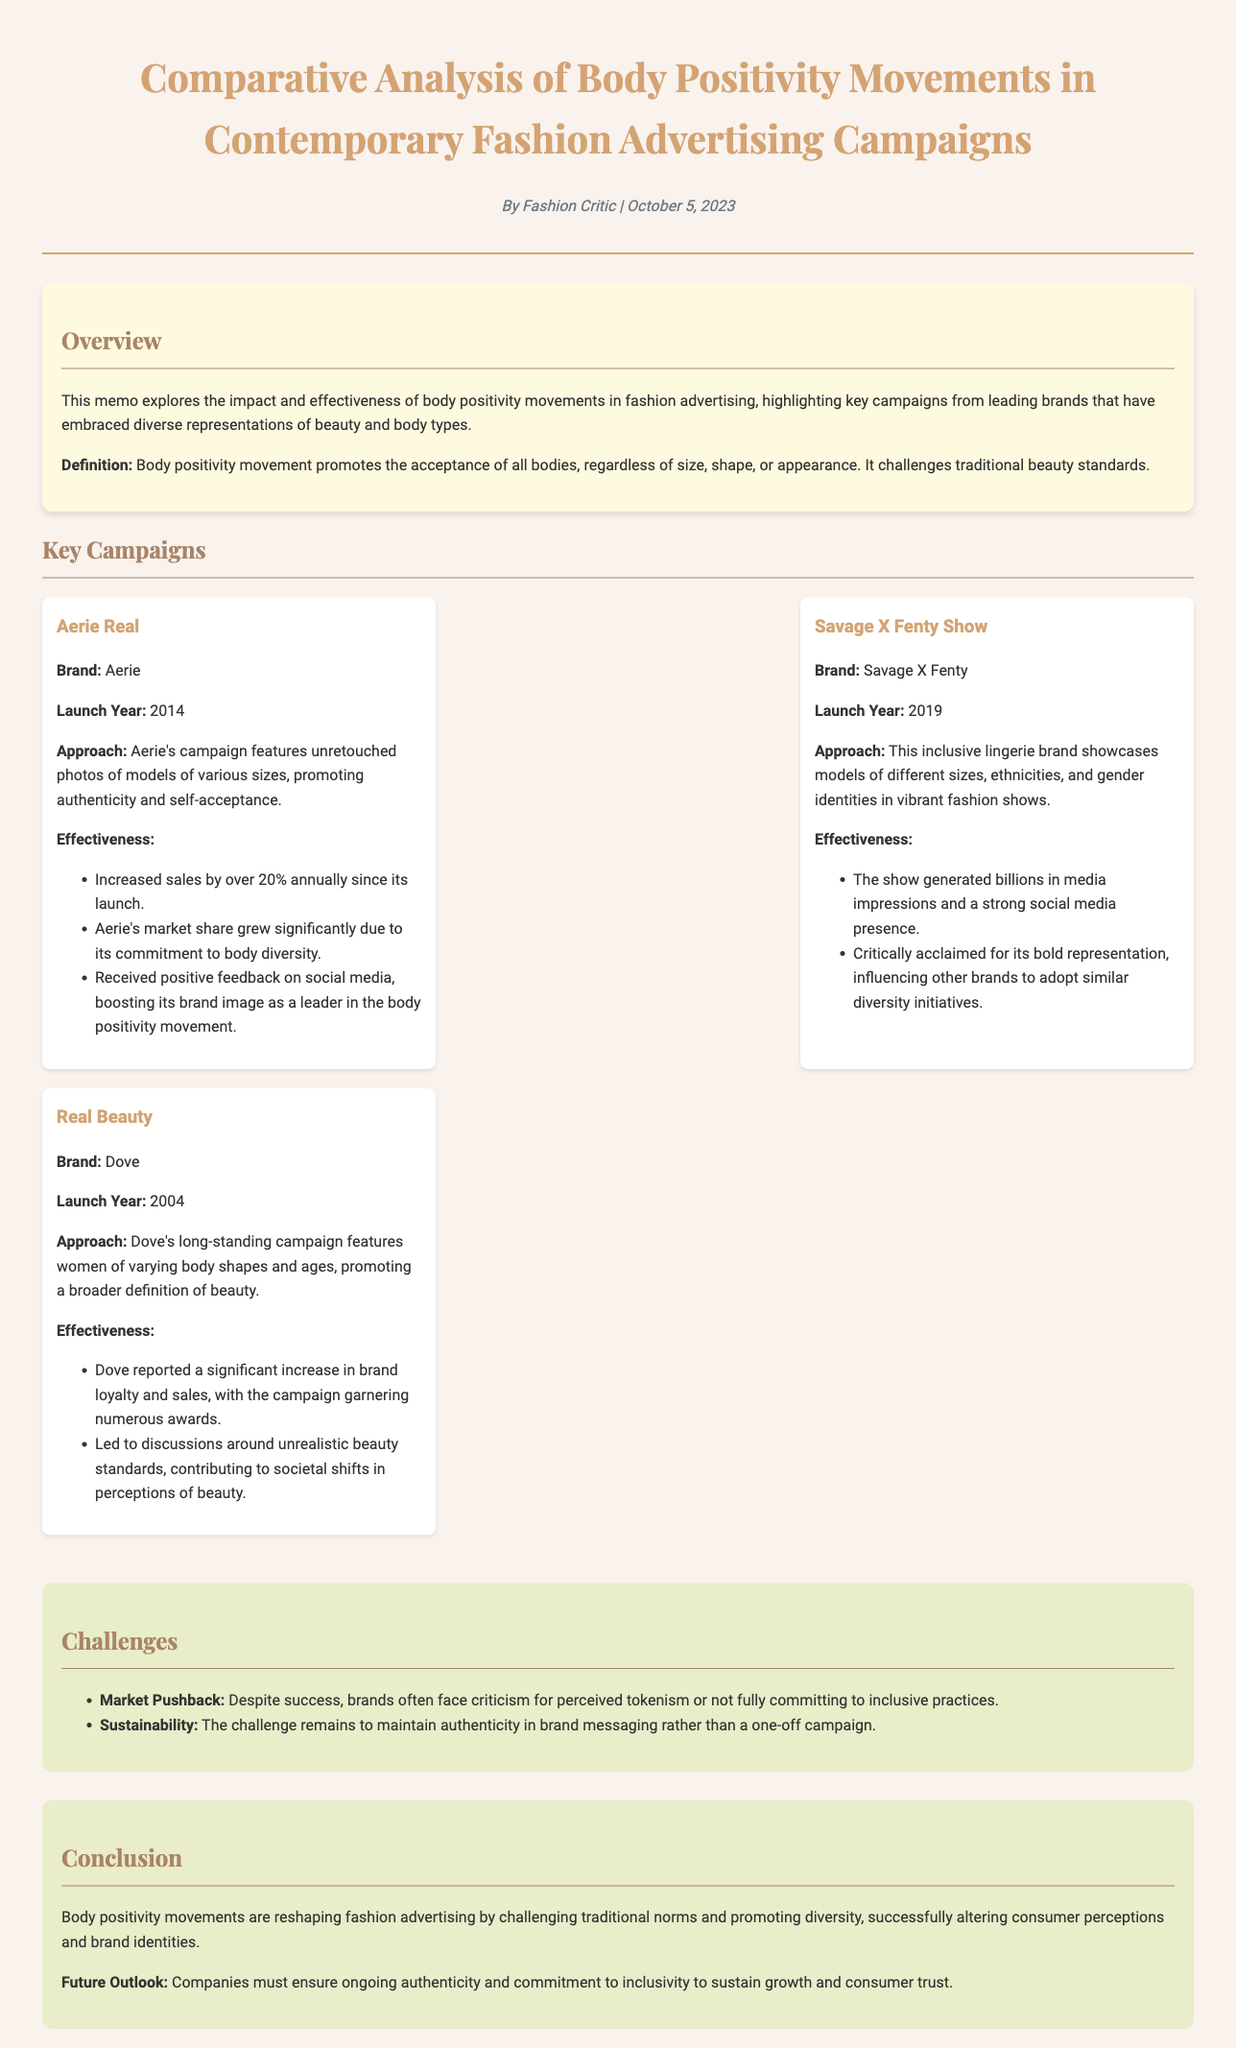What is the title of the memo? The title of the memo is explicitly stated in the header section.
Answer: Comparative Analysis of Body Positivity Movements in Contemporary Fashion Advertising Campaigns What is the publication date? The publication date is provided in the author-date line of the header section.
Answer: October 5, 2023 Which brand launched the "Aerie Real" campaign? The specific brand associated with the campaign is mentioned directly under the campaign title.
Answer: Aerie What year did Dove launch the "Real Beauty" campaign? The launch year is listed in the campaign details section under Dove.
Answer: 2004 What percentage did Aerie's sales increase annually since the campaign launch? The effectiveness of Aerie's campaign mentions the specific percentage increase in sales.
Answer: 20% What is one challenge faced by brands regarding body positivity movements? The challenges section lists specific issues brands face, one being highlighted here.
Answer: Market Pushback How did the "Savage X Fenty Show" influence other brands? The effectiveness section of this campaign states the impact it had on other brands' initiatives.
Answer: Influencing other brands to adopt similar diversity initiatives What is the main purpose of the body positivity movement? The definition of the body positivity movement is clearly stated in the overview section.
Answer: Promotes the acceptance of all bodies What is indicated as necessary for companies to maintain growth? The conclusion section summarizes future needs for brands in relation to body positivity movements.
Answer: Ongoing authenticity and commitment to inclusivity 